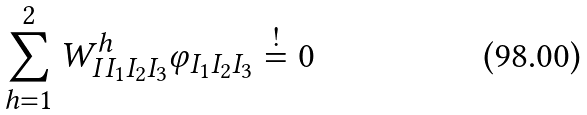Convert formula to latex. <formula><loc_0><loc_0><loc_500><loc_500>\sum _ { h = 1 } ^ { 2 } W ^ { h } _ { I I _ { 1 } I _ { 2 } I _ { 3 } } \varphi _ { I _ { 1 } I _ { 2 } I _ { 3 } } \stackrel { ! } { = } 0</formula> 